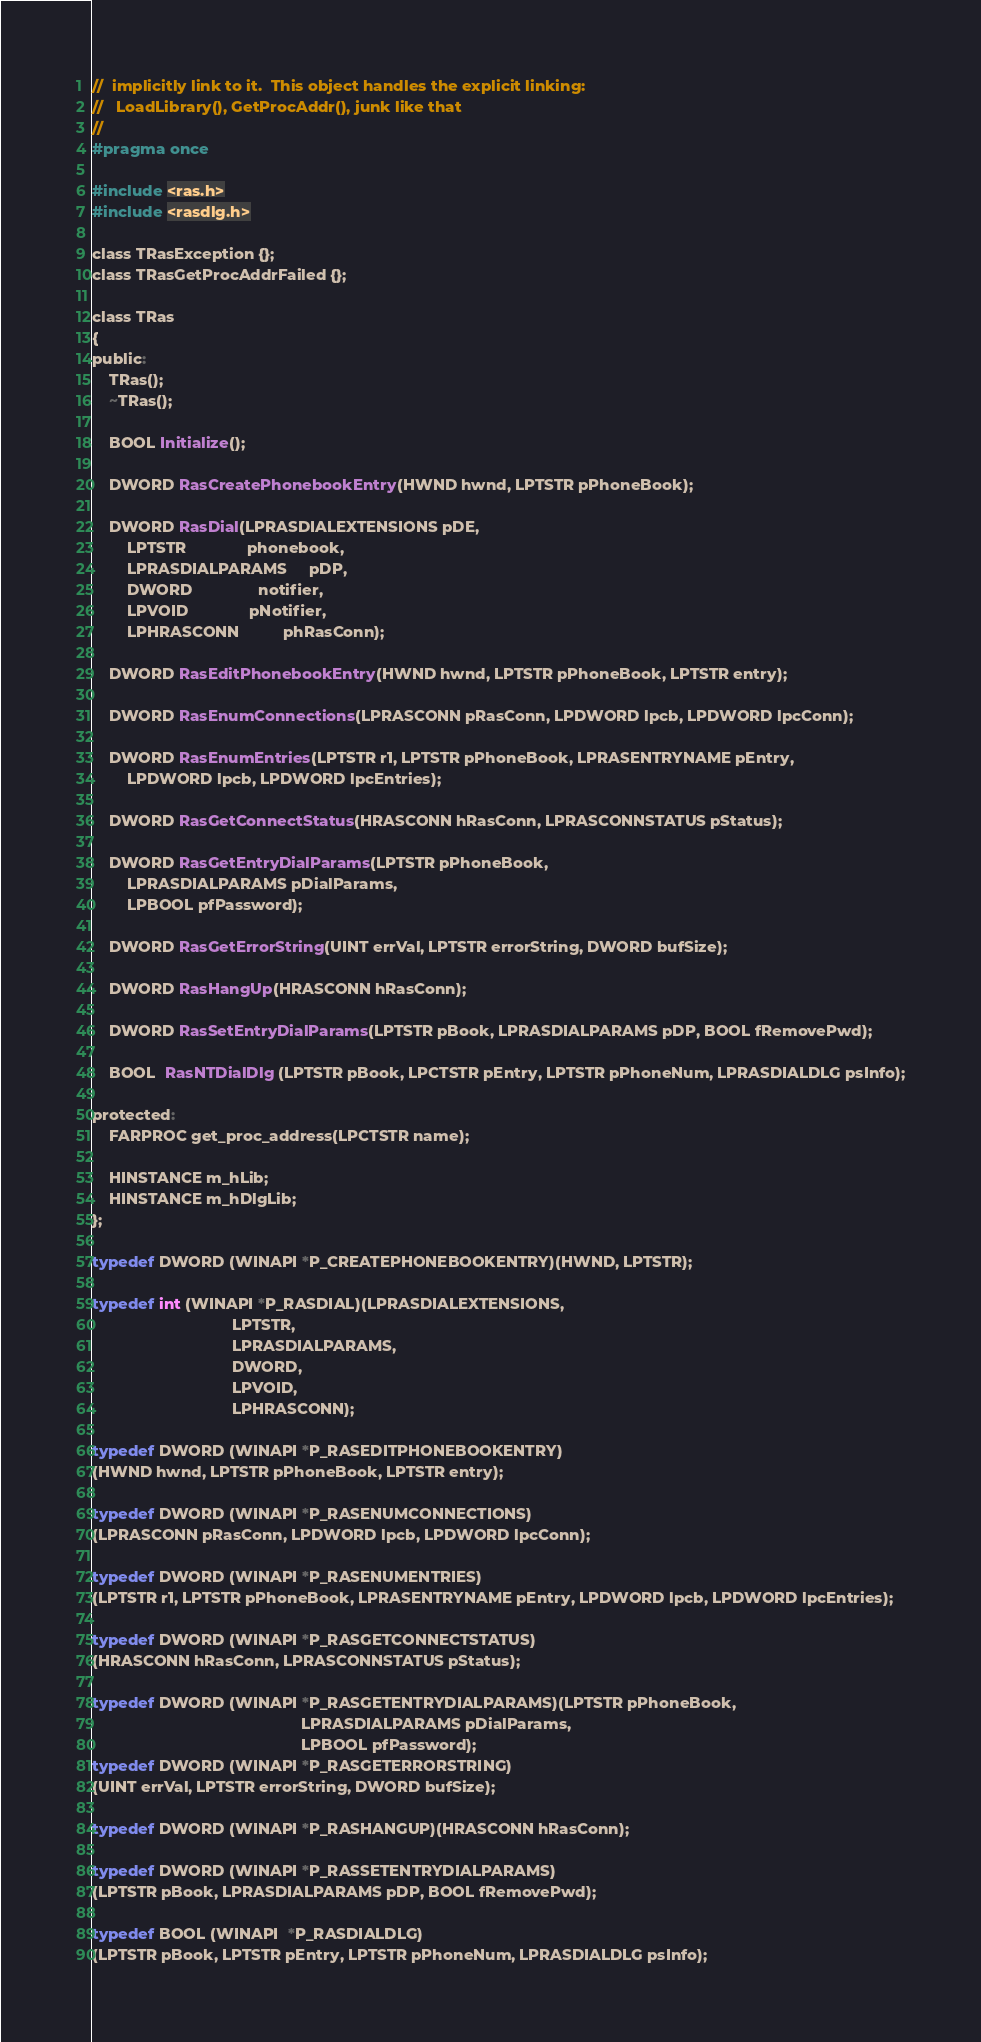Convert code to text. <code><loc_0><loc_0><loc_500><loc_500><_C_>//  implicitly link to it.  This object handles the explicit linking:
//   LoadLibrary(), GetProcAddr(), junk like that
//
#pragma once

#include <ras.h>
#include <rasdlg.h>

class TRasException {};
class TRasGetProcAddrFailed {};

class TRas
{
public:
	TRas();
	~TRas();

	BOOL Initialize();

	DWORD RasCreatePhonebookEntry(HWND hwnd, LPTSTR pPhoneBook);

	DWORD RasDial(LPRASDIALEXTENSIONS pDE,
		LPTSTR              phonebook,
		LPRASDIALPARAMS     pDP,
		DWORD               notifier,
		LPVOID              pNotifier,
		LPHRASCONN          phRasConn);

	DWORD RasEditPhonebookEntry(HWND hwnd, LPTSTR pPhoneBook, LPTSTR entry);

	DWORD RasEnumConnections(LPRASCONN pRasConn, LPDWORD lpcb, LPDWORD lpcConn);

	DWORD RasEnumEntries(LPTSTR r1, LPTSTR pPhoneBook, LPRASENTRYNAME pEntry,
		LPDWORD lpcb, LPDWORD lpcEntries);

	DWORD RasGetConnectStatus(HRASCONN hRasConn, LPRASCONNSTATUS pStatus);

	DWORD RasGetEntryDialParams(LPTSTR pPhoneBook,
		LPRASDIALPARAMS pDialParams,
		LPBOOL pfPassword);

	DWORD RasGetErrorString(UINT errVal, LPTSTR errorString, DWORD bufSize);

	DWORD RasHangUp(HRASCONN hRasConn);

	DWORD RasSetEntryDialParams(LPTSTR pBook, LPRASDIALPARAMS pDP, BOOL fRemovePwd);

	BOOL  RasNTDialDlg (LPTSTR pBook, LPCTSTR pEntry, LPTSTR pPhoneNum, LPRASDIALDLG psInfo);

protected:
	FARPROC get_proc_address(LPCTSTR name);

	HINSTANCE m_hLib;
	HINSTANCE m_hDlgLib;
};

typedef DWORD (WINAPI *P_CREATEPHONEBOOKENTRY)(HWND, LPTSTR);

typedef int (WINAPI *P_RASDIAL)(LPRASDIALEXTENSIONS,
								LPTSTR,
								LPRASDIALPARAMS,
								DWORD,
								LPVOID,
								LPHRASCONN);

typedef DWORD (WINAPI *P_RASEDITPHONEBOOKENTRY)
(HWND hwnd, LPTSTR pPhoneBook, LPTSTR entry);

typedef DWORD (WINAPI *P_RASENUMCONNECTIONS)
(LPRASCONN pRasConn, LPDWORD lpcb, LPDWORD lpcConn);

typedef DWORD (WINAPI *P_RASENUMENTRIES)
(LPTSTR r1, LPTSTR pPhoneBook, LPRASENTRYNAME pEntry, LPDWORD lpcb, LPDWORD lpcEntries);

typedef DWORD (WINAPI *P_RASGETCONNECTSTATUS)
(HRASCONN hRasConn, LPRASCONNSTATUS pStatus);

typedef DWORD (WINAPI *P_RASGETENTRYDIALPARAMS)(LPTSTR pPhoneBook,
												LPRASDIALPARAMS pDialParams,
												LPBOOL pfPassword);
typedef DWORD (WINAPI *P_RASGETERRORSTRING)
(UINT errVal, LPTSTR errorString, DWORD bufSize);

typedef DWORD (WINAPI *P_RASHANGUP)(HRASCONN hRasConn);

typedef DWORD (WINAPI *P_RASSETENTRYDIALPARAMS)
(LPTSTR pBook, LPRASDIALPARAMS pDP, BOOL fRemovePwd);

typedef BOOL (WINAPI  *P_RASDIALDLG)
(LPTSTR pBook, LPTSTR pEntry, LPTSTR pPhoneNum, LPRASDIALDLG psInfo);
</code> 